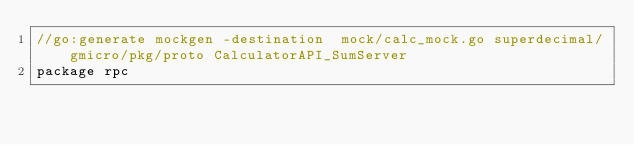Convert code to text. <code><loc_0><loc_0><loc_500><loc_500><_Go_>//go:generate mockgen -destination  mock/calc_mock.go superdecimal/gmicro/pkg/proto CalculatorAPI_SumServer
package rpc
</code> 